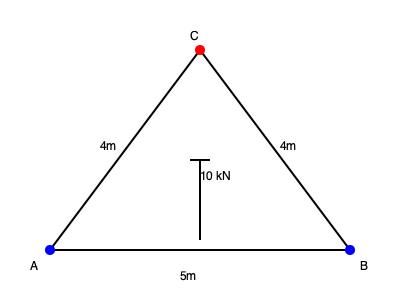Calcule la fuerza en la barra AC de la armadura simple mostrada en la figura. Una carga vertical de 10 kN se aplica en el punto C. Las dimensiones de la armadura son: AC = CB = 4m, y AB = 5m. Asuma que las conexiones en A y B son apoyos simples. Para resolver este problema, seguiremos estos pasos:

1) Primero, calculamos las reacciones en los apoyos A y B:
   Debido a la simetría, $R_A = R_B = 5$ kN

2) Ahora, consideramos el equilibrio del nodo C:
   $\sum F_y = 0$: $F_{AC}\sin\theta + F_{BC}\sin\theta - 10 = 0$
   $\sum F_x = 0$: $F_{AC}\cos\theta - F_{BC}\cos\theta = 0$

   Donde $\theta$ es el ángulo que forman AC y BC con la horizontal.

3) De la segunda ecuación, podemos deducir que $F_{AC} = F_{BC}$

4) Calculamos $\sin\theta$:
   $\sin\theta = \frac{4}{5} = 0.8$

5) Sustituyendo en la primera ecuación:
   $2F_{AC}(0.8) = 10$
   $F_{AC} = \frac{10}{1.6} = 6.25$ kN

6) Como la fuerza es positiva, la barra AC está en tensión.
Answer: 6.25 kN (tensión) 